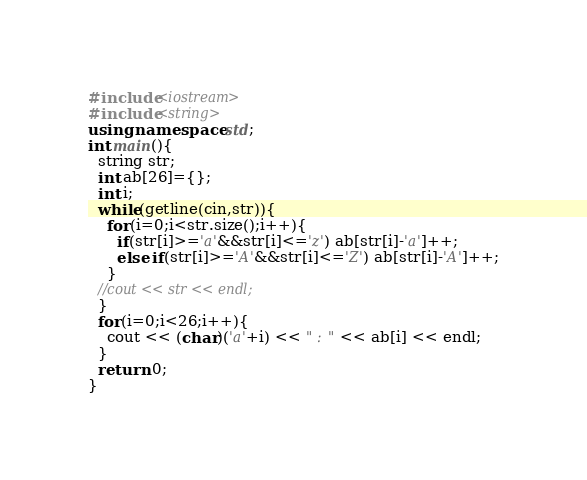Convert code to text. <code><loc_0><loc_0><loc_500><loc_500><_C++_>#include<iostream>
#include<string>
using namespace std;
int main(){
  string str;
  int ab[26]={};
  int i;
  while(getline(cin,str)){
    for(i=0;i<str.size();i++){
      if(str[i]>='a'&&str[i]<='z') ab[str[i]-'a']++;
      else if(str[i]>='A'&&str[i]<='Z') ab[str[i]-'A']++;
    }
  //cout << str << endl;
  }
  for(i=0;i<26;i++){
    cout << (char)('a'+i) << " : " << ab[i] << endl;
  }
  return 0;
}
</code> 